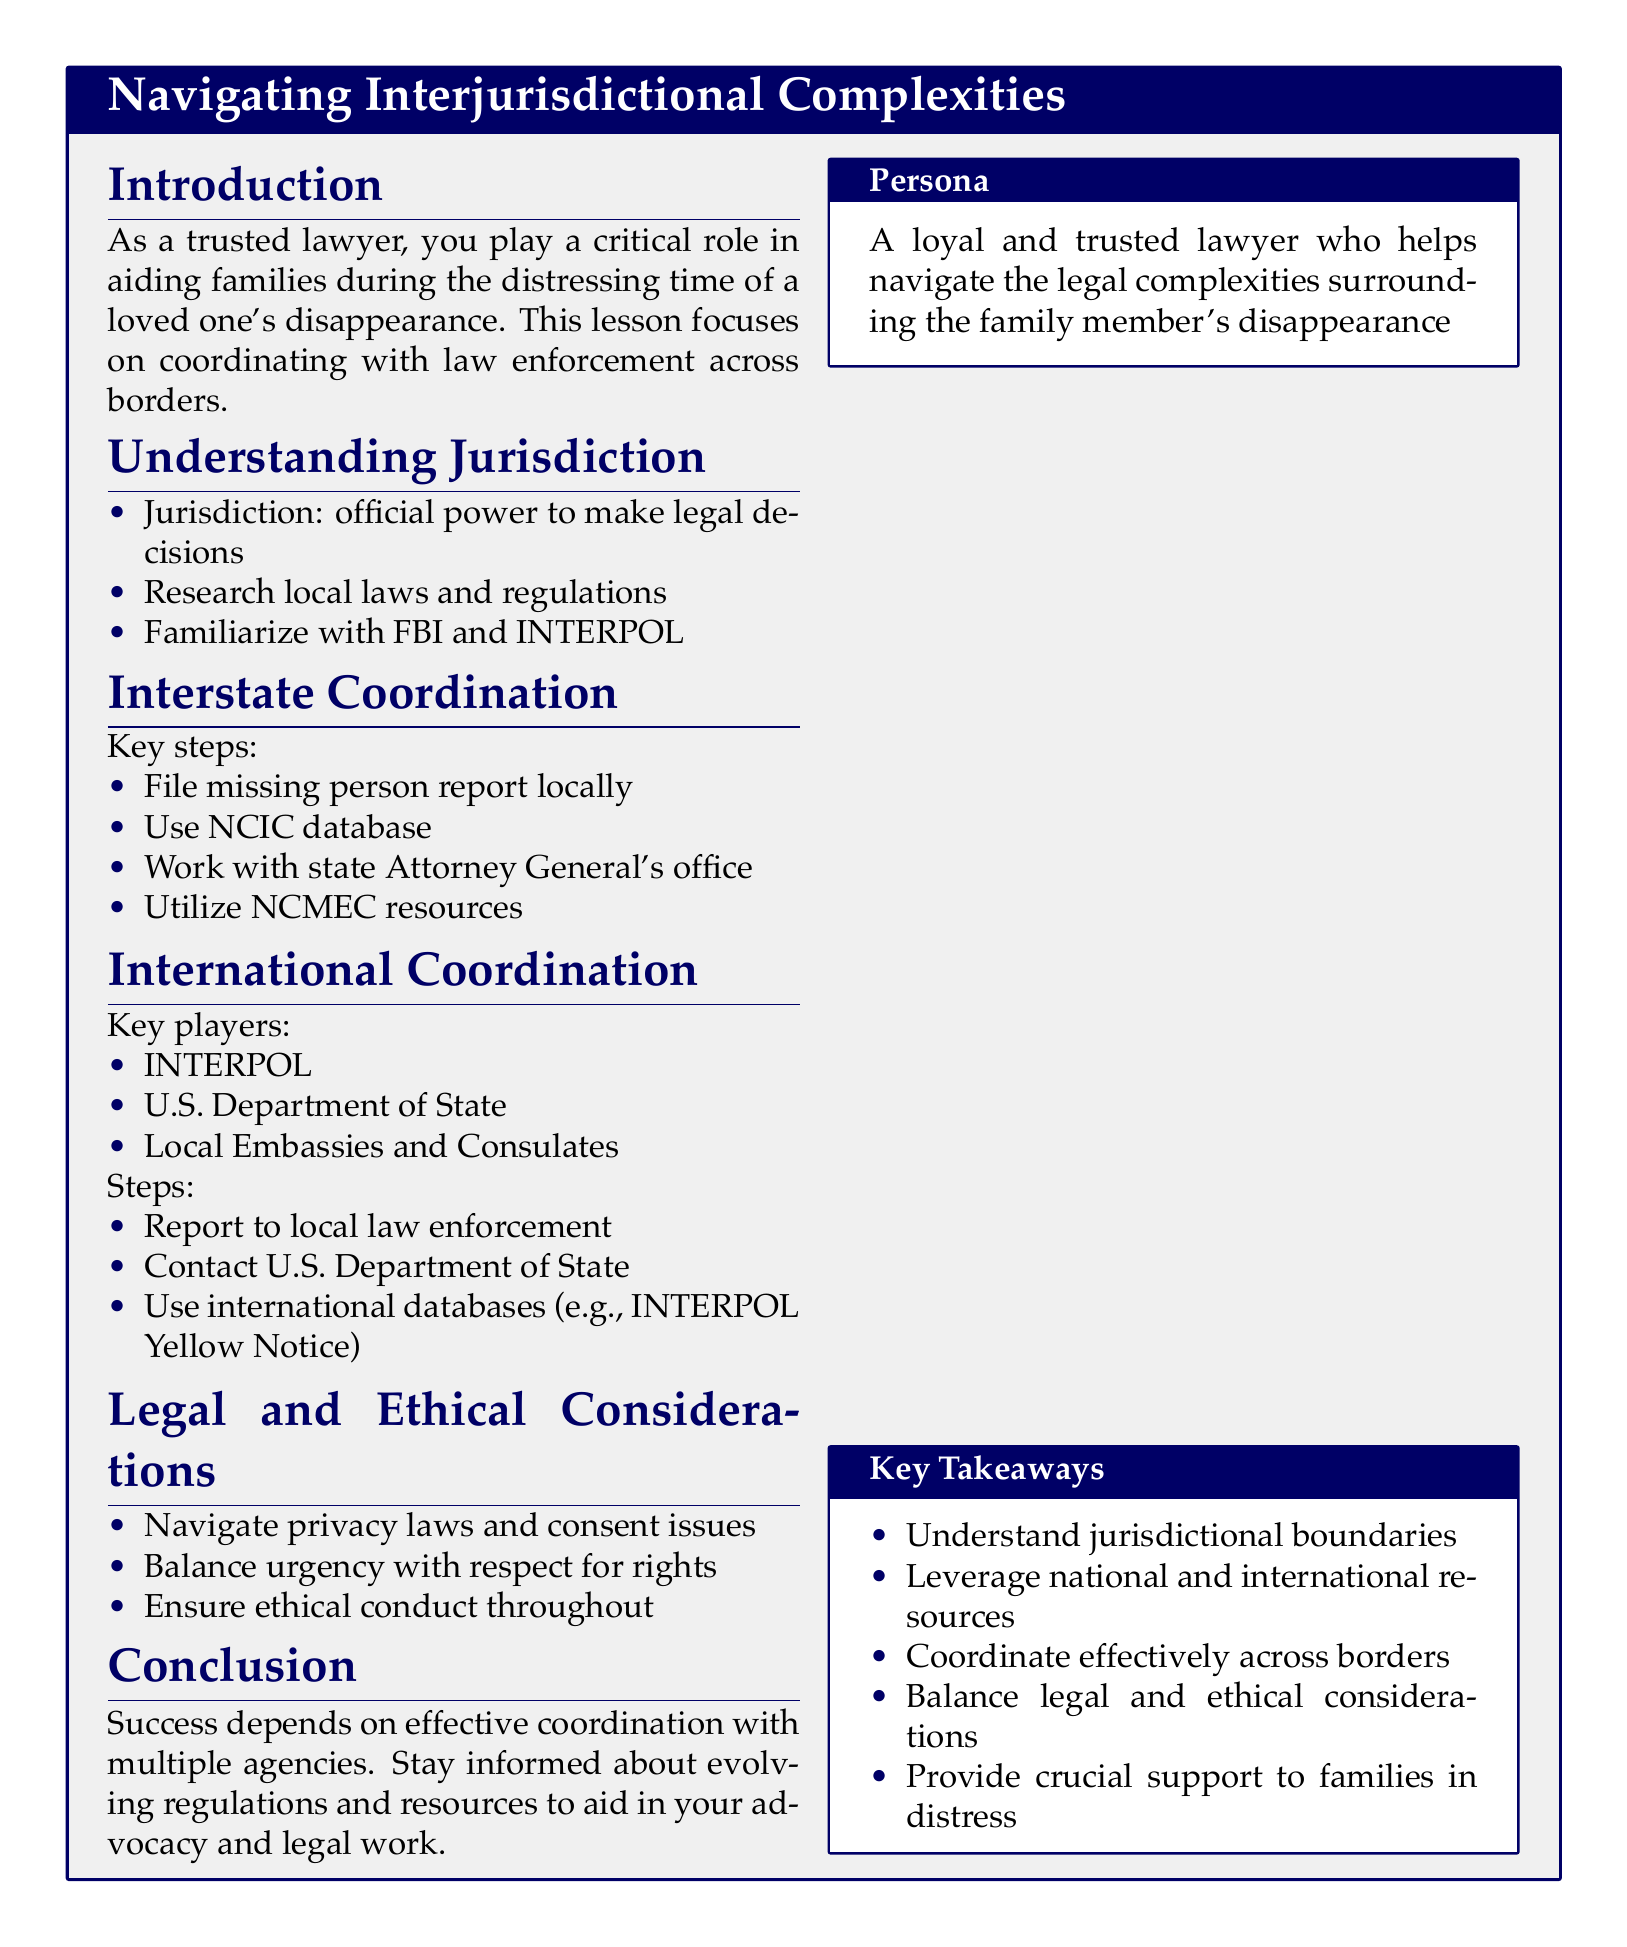What is the key focus of the lesson? The lesson focuses on coordinating with law enforcement across borders to find a missing family member.
Answer: Coordinating with law enforcement across borders What does jurisdiction refer to? Jurisdiction is the official power to make legal decisions as defined in the document.
Answer: Official power to make legal decisions What resources does the document suggest utilizing when working interstate? The document specifically mentions utilizing the NCMEC resources as a key step in interstate coordination.
Answer: NCMEC resources Who are the key players in international coordination? The key players include INTERPOL and the U.S. Department of State as listed in the document.
Answer: INTERPOL, U.S. Department of State Which database is recommended for use in interstate coordination? The document recommends using the NCIC database for interstate coordination.
Answer: NCIC database What is a legal consideration mentioned in the document? The document highlights the need to navigate privacy laws and consent issues as a legal consideration.
Answer: Navigate privacy laws and consent issues What ensures success in finding a missing family member according to the lesson? Effective coordination with multiple agencies is stated as crucial for success.
Answer: Effective coordination with multiple agencies What does the conclusion stress about staying informed? The conclusion stresses the importance of staying informed about evolving regulations and resources.
Answer: Staying informed about evolving regulations and resources 